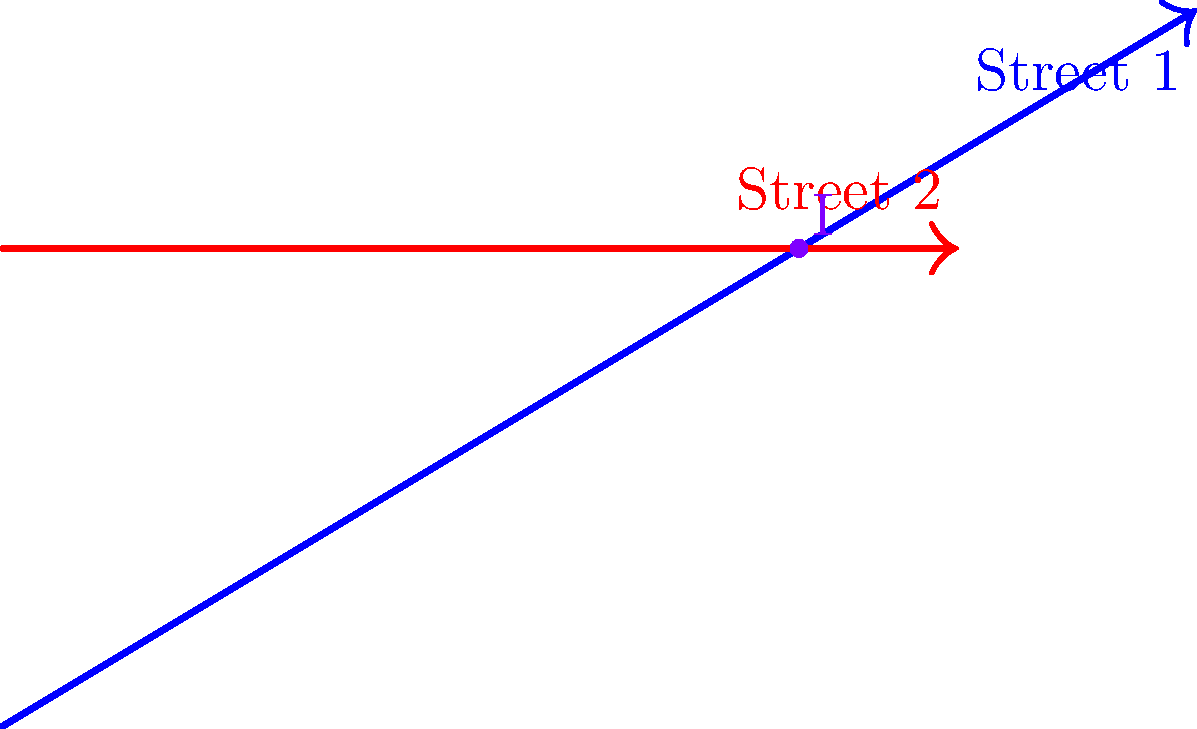In the city planning of Khartoum, two main streets are being mapped on a coordinate system. Street 1 is represented by the line passing through points (0,0) and (10,6), while Street 2 is represented by the line passing through points (0,4) and (8,4). At what coordinates do these two streets intersect? To find the intersection point, we need to follow these steps:

1) First, let's find the equations of both lines:

   For Street 1: 
   Slope $m_1 = \frac{6-0}{10-0} = \frac{3}{5}$
   Equation: $y = \frac{3}{5}x$

   For Street 2:
   Slope $m_2 = \frac{4-4}{8-0} = 0$
   Equation: $y = 4$

2) At the intersection point, the x and y coordinates will satisfy both equations. So we can set them equal:

   $\frac{3}{5}x = 4$

3) Solve for x:
   $x = 4 \cdot \frac{5}{3} = \frac{20}{3} \approx 6.67$

4) To find y, we can use either equation. Let's use $y = 4$

5) Therefore, the intersection point is $(\frac{20}{3}, 4)$ or approximately (6.67, 4)

This point represents where the two streets meet in our coordinate system of Khartoum's city plan.
Answer: $(\frac{20}{3}, 4)$ 